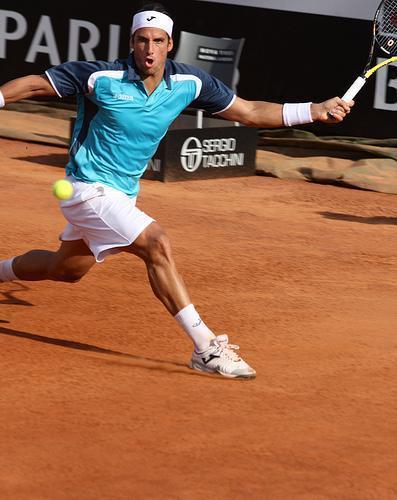How many tennis players are in the picture?
Give a very brief answer. 1. 